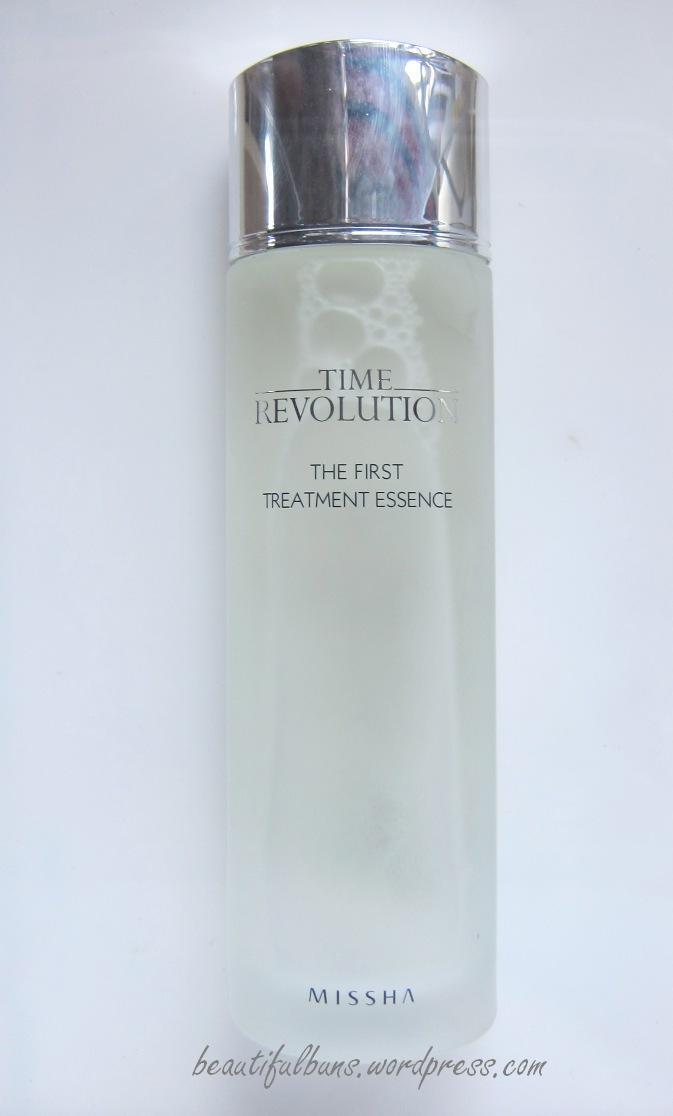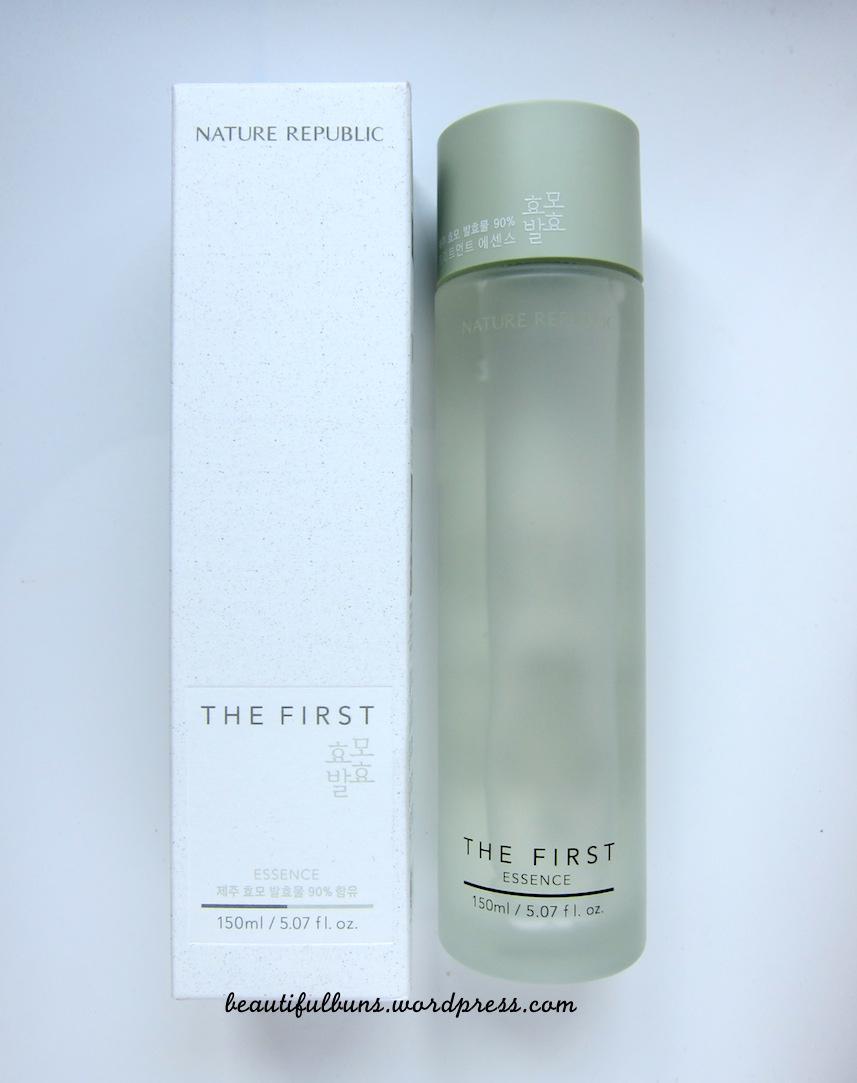The first image is the image on the left, the second image is the image on the right. Examine the images to the left and right. Is the description "The left image contains one fragrance bottle standing alone, and the right image contains a fragrance bottle to the right of its box." accurate? Answer yes or no. Yes. The first image is the image on the left, the second image is the image on the right. Assess this claim about the two images: "At least one bottle in the image on the left has a silver cap.". Correct or not? Answer yes or no. Yes. 